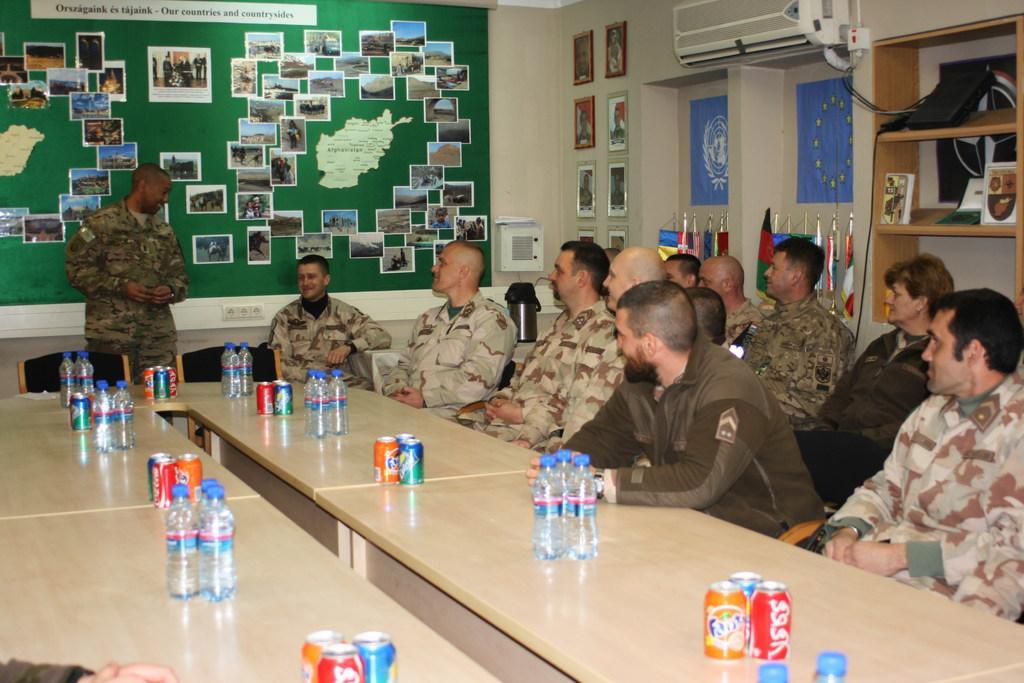In one or two sentences, can you explain what this image depicts? In this picture I can see few people are sitting on the chairs in front of the table, on which some bottles, tins are placed on the table, one person is standing and talking, behind I can see some photos on the board. 